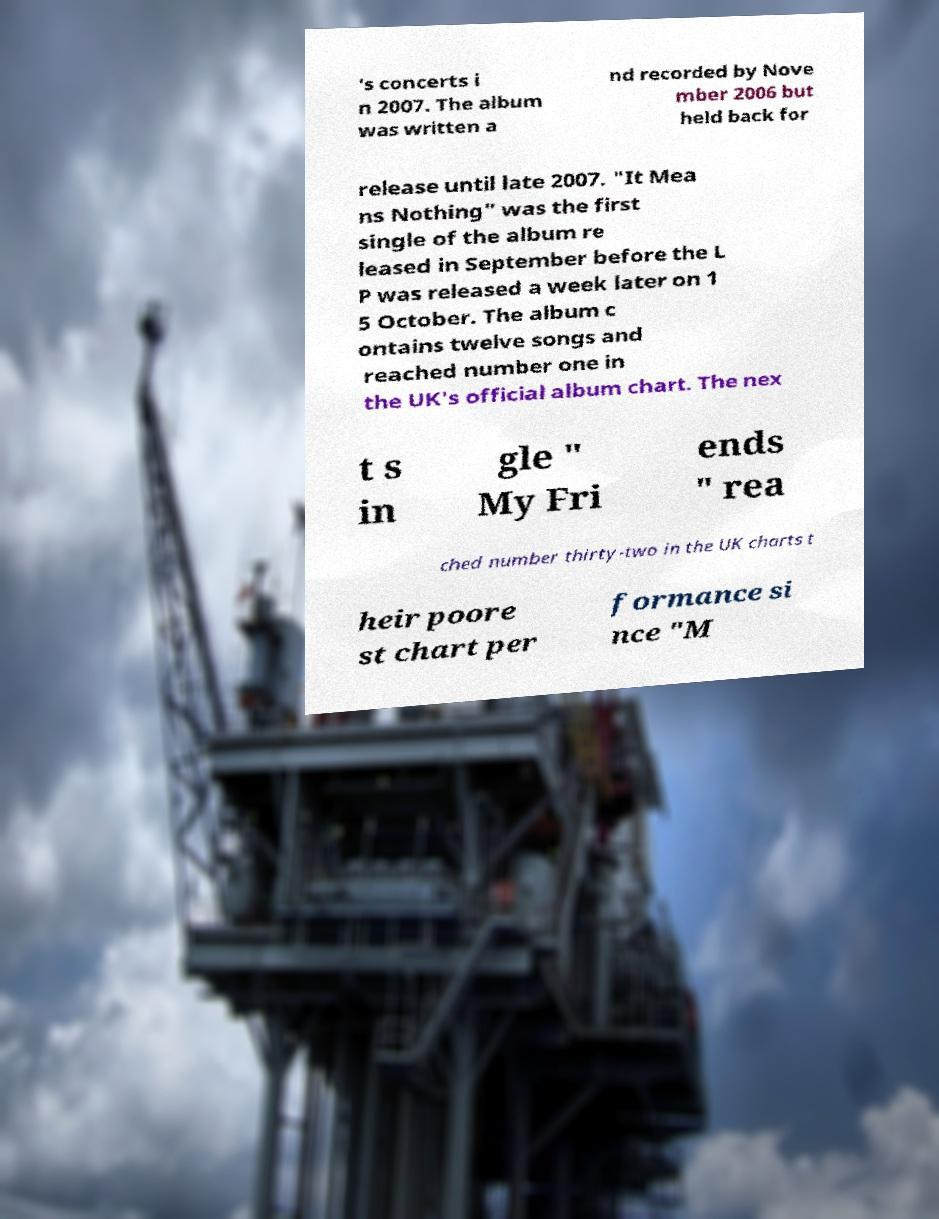Can you accurately transcribe the text from the provided image for me? 's concerts i n 2007. The album was written a nd recorded by Nove mber 2006 but held back for release until late 2007. "It Mea ns Nothing" was the first single of the album re leased in September before the L P was released a week later on 1 5 October. The album c ontains twelve songs and reached number one in the UK's official album chart. The nex t s in gle " My Fri ends " rea ched number thirty-two in the UK charts t heir poore st chart per formance si nce "M 